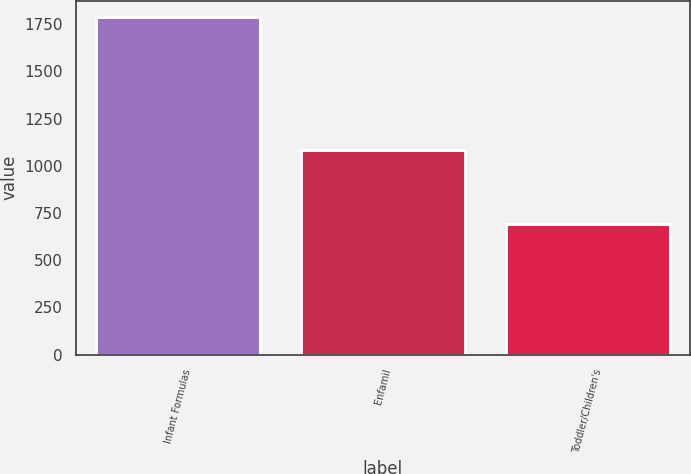<chart> <loc_0><loc_0><loc_500><loc_500><bar_chart><fcel>Infant Formulas<fcel>Enfamil<fcel>Toddler/Children's<nl><fcel>1786<fcel>1082<fcel>693<nl></chart> 